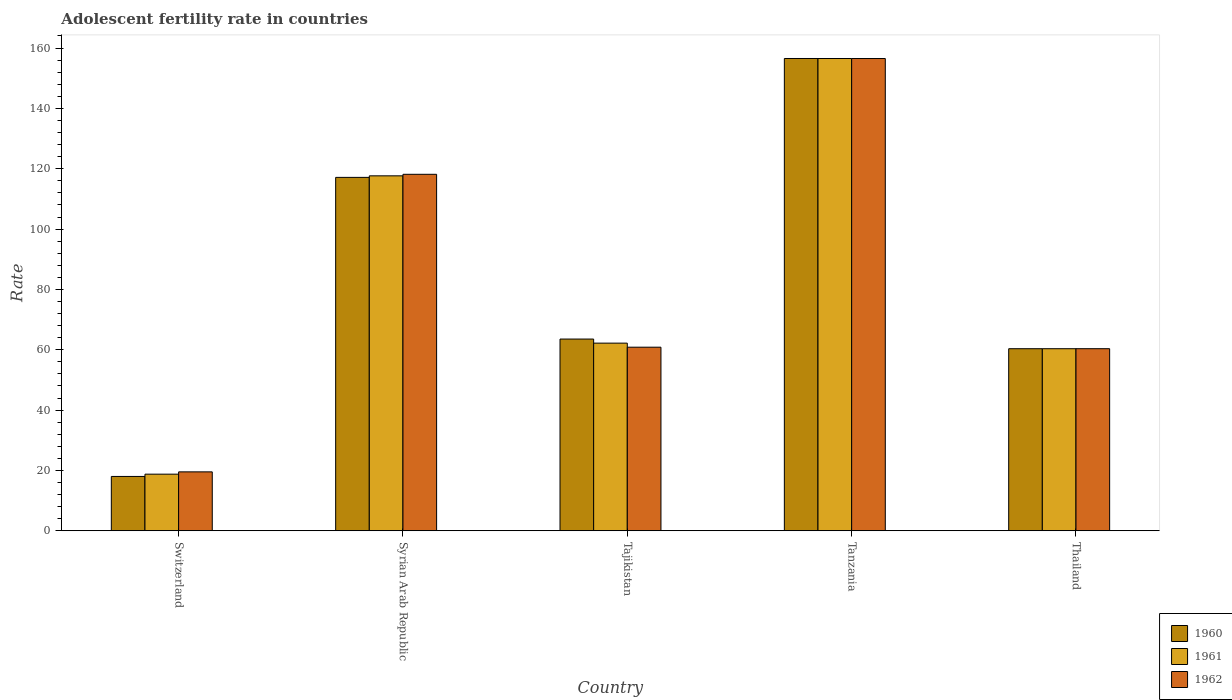How many different coloured bars are there?
Offer a very short reply. 3. How many groups of bars are there?
Provide a short and direct response. 5. Are the number of bars per tick equal to the number of legend labels?
Your answer should be very brief. Yes. What is the label of the 5th group of bars from the left?
Give a very brief answer. Thailand. What is the adolescent fertility rate in 1961 in Tanzania?
Give a very brief answer. 156.54. Across all countries, what is the maximum adolescent fertility rate in 1962?
Your answer should be very brief. 156.54. Across all countries, what is the minimum adolescent fertility rate in 1960?
Offer a very short reply. 18.01. In which country was the adolescent fertility rate in 1960 maximum?
Offer a terse response. Tanzania. In which country was the adolescent fertility rate in 1961 minimum?
Offer a terse response. Switzerland. What is the total adolescent fertility rate in 1962 in the graph?
Give a very brief answer. 415.43. What is the difference between the adolescent fertility rate in 1962 in Syrian Arab Republic and that in Thailand?
Ensure brevity in your answer.  57.81. What is the difference between the adolescent fertility rate in 1960 in Tajikistan and the adolescent fertility rate in 1962 in Thailand?
Make the answer very short. 3.2. What is the average adolescent fertility rate in 1961 per country?
Your response must be concise. 83.1. What is the difference between the adolescent fertility rate of/in 1961 and adolescent fertility rate of/in 1962 in Syrian Arab Republic?
Offer a terse response. -0.51. What is the ratio of the adolescent fertility rate in 1961 in Switzerland to that in Syrian Arab Republic?
Offer a very short reply. 0.16. What is the difference between the highest and the second highest adolescent fertility rate in 1961?
Offer a terse response. 38.89. What is the difference between the highest and the lowest adolescent fertility rate in 1960?
Your answer should be very brief. 138.53. In how many countries, is the adolescent fertility rate in 1962 greater than the average adolescent fertility rate in 1962 taken over all countries?
Your answer should be very brief. 2. Is the sum of the adolescent fertility rate in 1960 in Syrian Arab Republic and Tajikistan greater than the maximum adolescent fertility rate in 1961 across all countries?
Keep it short and to the point. Yes. What does the 1st bar from the left in Tanzania represents?
Make the answer very short. 1960. What does the 3rd bar from the right in Thailand represents?
Your answer should be very brief. 1960. Is it the case that in every country, the sum of the adolescent fertility rate in 1962 and adolescent fertility rate in 1961 is greater than the adolescent fertility rate in 1960?
Offer a terse response. Yes. How many bars are there?
Keep it short and to the point. 15. Are all the bars in the graph horizontal?
Provide a succinct answer. No. How many countries are there in the graph?
Provide a succinct answer. 5. Are the values on the major ticks of Y-axis written in scientific E-notation?
Keep it short and to the point. No. Where does the legend appear in the graph?
Provide a succinct answer. Bottom right. How are the legend labels stacked?
Give a very brief answer. Vertical. What is the title of the graph?
Give a very brief answer. Adolescent fertility rate in countries. Does "2005" appear as one of the legend labels in the graph?
Your answer should be compact. No. What is the label or title of the Y-axis?
Give a very brief answer. Rate. What is the Rate of 1960 in Switzerland?
Your answer should be very brief. 18.01. What is the Rate of 1961 in Switzerland?
Your answer should be compact. 18.77. What is the Rate in 1962 in Switzerland?
Make the answer very short. 19.53. What is the Rate of 1960 in Syrian Arab Republic?
Offer a very short reply. 117.14. What is the Rate of 1961 in Syrian Arab Republic?
Offer a very short reply. 117.65. What is the Rate of 1962 in Syrian Arab Republic?
Give a very brief answer. 118.16. What is the Rate of 1960 in Tajikistan?
Offer a terse response. 63.55. What is the Rate in 1961 in Tajikistan?
Your answer should be compact. 62.2. What is the Rate of 1962 in Tajikistan?
Offer a very short reply. 60.85. What is the Rate of 1960 in Tanzania?
Your answer should be very brief. 156.55. What is the Rate of 1961 in Tanzania?
Keep it short and to the point. 156.54. What is the Rate of 1962 in Tanzania?
Give a very brief answer. 156.54. What is the Rate in 1960 in Thailand?
Your response must be concise. 60.35. What is the Rate of 1961 in Thailand?
Offer a terse response. 60.35. What is the Rate of 1962 in Thailand?
Your response must be concise. 60.35. Across all countries, what is the maximum Rate in 1960?
Provide a succinct answer. 156.55. Across all countries, what is the maximum Rate in 1961?
Make the answer very short. 156.54. Across all countries, what is the maximum Rate of 1962?
Offer a very short reply. 156.54. Across all countries, what is the minimum Rate in 1960?
Ensure brevity in your answer.  18.01. Across all countries, what is the minimum Rate of 1961?
Offer a very short reply. 18.77. Across all countries, what is the minimum Rate of 1962?
Offer a very short reply. 19.53. What is the total Rate in 1960 in the graph?
Give a very brief answer. 415.59. What is the total Rate of 1961 in the graph?
Make the answer very short. 415.51. What is the total Rate of 1962 in the graph?
Your response must be concise. 415.43. What is the difference between the Rate in 1960 in Switzerland and that in Syrian Arab Republic?
Your response must be concise. -99.13. What is the difference between the Rate of 1961 in Switzerland and that in Syrian Arab Republic?
Your answer should be very brief. -98.88. What is the difference between the Rate of 1962 in Switzerland and that in Syrian Arab Republic?
Provide a succinct answer. -98.63. What is the difference between the Rate in 1960 in Switzerland and that in Tajikistan?
Your response must be concise. -45.54. What is the difference between the Rate of 1961 in Switzerland and that in Tajikistan?
Your answer should be compact. -43.43. What is the difference between the Rate of 1962 in Switzerland and that in Tajikistan?
Provide a short and direct response. -41.32. What is the difference between the Rate of 1960 in Switzerland and that in Tanzania?
Offer a very short reply. -138.53. What is the difference between the Rate of 1961 in Switzerland and that in Tanzania?
Make the answer very short. -137.77. What is the difference between the Rate in 1962 in Switzerland and that in Tanzania?
Ensure brevity in your answer.  -137.01. What is the difference between the Rate of 1960 in Switzerland and that in Thailand?
Offer a terse response. -42.34. What is the difference between the Rate of 1961 in Switzerland and that in Thailand?
Make the answer very short. -41.58. What is the difference between the Rate in 1962 in Switzerland and that in Thailand?
Keep it short and to the point. -40.82. What is the difference between the Rate in 1960 in Syrian Arab Republic and that in Tajikistan?
Provide a short and direct response. 53.59. What is the difference between the Rate in 1961 in Syrian Arab Republic and that in Tajikistan?
Give a very brief answer. 55.45. What is the difference between the Rate in 1962 in Syrian Arab Republic and that in Tajikistan?
Make the answer very short. 57.31. What is the difference between the Rate of 1960 in Syrian Arab Republic and that in Tanzania?
Your answer should be very brief. -39.41. What is the difference between the Rate of 1961 in Syrian Arab Republic and that in Tanzania?
Offer a terse response. -38.89. What is the difference between the Rate of 1962 in Syrian Arab Republic and that in Tanzania?
Make the answer very short. -38.38. What is the difference between the Rate in 1960 in Syrian Arab Republic and that in Thailand?
Your response must be concise. 56.79. What is the difference between the Rate of 1961 in Syrian Arab Republic and that in Thailand?
Ensure brevity in your answer.  57.3. What is the difference between the Rate in 1962 in Syrian Arab Republic and that in Thailand?
Keep it short and to the point. 57.81. What is the difference between the Rate of 1960 in Tajikistan and that in Tanzania?
Your response must be concise. -93. What is the difference between the Rate in 1961 in Tajikistan and that in Tanzania?
Keep it short and to the point. -94.34. What is the difference between the Rate of 1962 in Tajikistan and that in Tanzania?
Make the answer very short. -95.68. What is the difference between the Rate in 1960 in Tajikistan and that in Thailand?
Offer a very short reply. 3.2. What is the difference between the Rate in 1961 in Tajikistan and that in Thailand?
Your response must be concise. 1.85. What is the difference between the Rate in 1962 in Tajikistan and that in Thailand?
Provide a short and direct response. 0.5. What is the difference between the Rate in 1960 in Tanzania and that in Thailand?
Offer a terse response. 96.19. What is the difference between the Rate of 1961 in Tanzania and that in Thailand?
Your answer should be compact. 96.19. What is the difference between the Rate in 1962 in Tanzania and that in Thailand?
Your answer should be compact. 96.18. What is the difference between the Rate in 1960 in Switzerland and the Rate in 1961 in Syrian Arab Republic?
Offer a very short reply. -99.64. What is the difference between the Rate of 1960 in Switzerland and the Rate of 1962 in Syrian Arab Republic?
Ensure brevity in your answer.  -100.15. What is the difference between the Rate of 1961 in Switzerland and the Rate of 1962 in Syrian Arab Republic?
Offer a very short reply. -99.39. What is the difference between the Rate of 1960 in Switzerland and the Rate of 1961 in Tajikistan?
Make the answer very short. -44.19. What is the difference between the Rate of 1960 in Switzerland and the Rate of 1962 in Tajikistan?
Offer a very short reply. -42.84. What is the difference between the Rate in 1961 in Switzerland and the Rate in 1962 in Tajikistan?
Your answer should be compact. -42.08. What is the difference between the Rate in 1960 in Switzerland and the Rate in 1961 in Tanzania?
Give a very brief answer. -138.53. What is the difference between the Rate in 1960 in Switzerland and the Rate in 1962 in Tanzania?
Give a very brief answer. -138.52. What is the difference between the Rate of 1961 in Switzerland and the Rate of 1962 in Tanzania?
Your answer should be compact. -137.77. What is the difference between the Rate in 1960 in Switzerland and the Rate in 1961 in Thailand?
Offer a very short reply. -42.34. What is the difference between the Rate of 1960 in Switzerland and the Rate of 1962 in Thailand?
Your response must be concise. -42.34. What is the difference between the Rate of 1961 in Switzerland and the Rate of 1962 in Thailand?
Your answer should be compact. -41.58. What is the difference between the Rate in 1960 in Syrian Arab Republic and the Rate in 1961 in Tajikistan?
Offer a terse response. 54.94. What is the difference between the Rate in 1960 in Syrian Arab Republic and the Rate in 1962 in Tajikistan?
Give a very brief answer. 56.29. What is the difference between the Rate of 1961 in Syrian Arab Republic and the Rate of 1962 in Tajikistan?
Keep it short and to the point. 56.8. What is the difference between the Rate of 1960 in Syrian Arab Republic and the Rate of 1961 in Tanzania?
Offer a terse response. -39.4. What is the difference between the Rate in 1960 in Syrian Arab Republic and the Rate in 1962 in Tanzania?
Your response must be concise. -39.4. What is the difference between the Rate in 1961 in Syrian Arab Republic and the Rate in 1962 in Tanzania?
Your response must be concise. -38.89. What is the difference between the Rate of 1960 in Syrian Arab Republic and the Rate of 1961 in Thailand?
Offer a terse response. 56.79. What is the difference between the Rate in 1960 in Syrian Arab Republic and the Rate in 1962 in Thailand?
Offer a terse response. 56.78. What is the difference between the Rate in 1961 in Syrian Arab Republic and the Rate in 1962 in Thailand?
Your answer should be compact. 57.3. What is the difference between the Rate of 1960 in Tajikistan and the Rate of 1961 in Tanzania?
Give a very brief answer. -92.99. What is the difference between the Rate in 1960 in Tajikistan and the Rate in 1962 in Tanzania?
Make the answer very short. -92.99. What is the difference between the Rate of 1961 in Tajikistan and the Rate of 1962 in Tanzania?
Ensure brevity in your answer.  -94.34. What is the difference between the Rate of 1960 in Tajikistan and the Rate of 1961 in Thailand?
Your response must be concise. 3.2. What is the difference between the Rate in 1960 in Tajikistan and the Rate in 1962 in Thailand?
Your answer should be very brief. 3.2. What is the difference between the Rate in 1961 in Tajikistan and the Rate in 1962 in Thailand?
Offer a terse response. 1.85. What is the difference between the Rate in 1960 in Tanzania and the Rate in 1961 in Thailand?
Your answer should be compact. 96.19. What is the difference between the Rate of 1960 in Tanzania and the Rate of 1962 in Thailand?
Offer a very short reply. 96.19. What is the difference between the Rate in 1961 in Tanzania and the Rate in 1962 in Thailand?
Your answer should be very brief. 96.19. What is the average Rate in 1960 per country?
Ensure brevity in your answer.  83.12. What is the average Rate of 1961 per country?
Make the answer very short. 83.1. What is the average Rate in 1962 per country?
Provide a short and direct response. 83.09. What is the difference between the Rate of 1960 and Rate of 1961 in Switzerland?
Your response must be concise. -0.76. What is the difference between the Rate of 1960 and Rate of 1962 in Switzerland?
Keep it short and to the point. -1.52. What is the difference between the Rate in 1961 and Rate in 1962 in Switzerland?
Offer a very short reply. -0.76. What is the difference between the Rate of 1960 and Rate of 1961 in Syrian Arab Republic?
Your answer should be compact. -0.51. What is the difference between the Rate in 1960 and Rate in 1962 in Syrian Arab Republic?
Provide a short and direct response. -1.02. What is the difference between the Rate in 1961 and Rate in 1962 in Syrian Arab Republic?
Give a very brief answer. -0.51. What is the difference between the Rate in 1960 and Rate in 1961 in Tajikistan?
Offer a terse response. 1.35. What is the difference between the Rate of 1960 and Rate of 1962 in Tajikistan?
Keep it short and to the point. 2.7. What is the difference between the Rate in 1961 and Rate in 1962 in Tajikistan?
Give a very brief answer. 1.35. What is the difference between the Rate of 1960 and Rate of 1961 in Tanzania?
Keep it short and to the point. 0. What is the difference between the Rate in 1960 and Rate in 1962 in Tanzania?
Your answer should be very brief. 0.01. What is the difference between the Rate in 1961 and Rate in 1962 in Tanzania?
Your answer should be very brief. 0. What is the difference between the Rate in 1960 and Rate in 1961 in Thailand?
Your answer should be very brief. -0. What is the difference between the Rate in 1960 and Rate in 1962 in Thailand?
Offer a terse response. -0. What is the difference between the Rate in 1961 and Rate in 1962 in Thailand?
Your response must be concise. -0. What is the ratio of the Rate of 1960 in Switzerland to that in Syrian Arab Republic?
Your response must be concise. 0.15. What is the ratio of the Rate of 1961 in Switzerland to that in Syrian Arab Republic?
Give a very brief answer. 0.16. What is the ratio of the Rate in 1962 in Switzerland to that in Syrian Arab Republic?
Provide a short and direct response. 0.17. What is the ratio of the Rate of 1960 in Switzerland to that in Tajikistan?
Your answer should be very brief. 0.28. What is the ratio of the Rate of 1961 in Switzerland to that in Tajikistan?
Offer a very short reply. 0.3. What is the ratio of the Rate in 1962 in Switzerland to that in Tajikistan?
Ensure brevity in your answer.  0.32. What is the ratio of the Rate in 1960 in Switzerland to that in Tanzania?
Provide a succinct answer. 0.12. What is the ratio of the Rate of 1961 in Switzerland to that in Tanzania?
Provide a succinct answer. 0.12. What is the ratio of the Rate of 1962 in Switzerland to that in Tanzania?
Your answer should be very brief. 0.12. What is the ratio of the Rate in 1960 in Switzerland to that in Thailand?
Your response must be concise. 0.3. What is the ratio of the Rate of 1961 in Switzerland to that in Thailand?
Give a very brief answer. 0.31. What is the ratio of the Rate of 1962 in Switzerland to that in Thailand?
Keep it short and to the point. 0.32. What is the ratio of the Rate of 1960 in Syrian Arab Republic to that in Tajikistan?
Give a very brief answer. 1.84. What is the ratio of the Rate in 1961 in Syrian Arab Republic to that in Tajikistan?
Provide a succinct answer. 1.89. What is the ratio of the Rate of 1962 in Syrian Arab Republic to that in Tajikistan?
Offer a very short reply. 1.94. What is the ratio of the Rate in 1960 in Syrian Arab Republic to that in Tanzania?
Offer a terse response. 0.75. What is the ratio of the Rate of 1961 in Syrian Arab Republic to that in Tanzania?
Make the answer very short. 0.75. What is the ratio of the Rate in 1962 in Syrian Arab Republic to that in Tanzania?
Give a very brief answer. 0.75. What is the ratio of the Rate of 1960 in Syrian Arab Republic to that in Thailand?
Offer a very short reply. 1.94. What is the ratio of the Rate in 1961 in Syrian Arab Republic to that in Thailand?
Ensure brevity in your answer.  1.95. What is the ratio of the Rate of 1962 in Syrian Arab Republic to that in Thailand?
Keep it short and to the point. 1.96. What is the ratio of the Rate of 1960 in Tajikistan to that in Tanzania?
Provide a short and direct response. 0.41. What is the ratio of the Rate of 1961 in Tajikistan to that in Tanzania?
Offer a very short reply. 0.4. What is the ratio of the Rate of 1962 in Tajikistan to that in Tanzania?
Provide a short and direct response. 0.39. What is the ratio of the Rate of 1960 in Tajikistan to that in Thailand?
Give a very brief answer. 1.05. What is the ratio of the Rate in 1961 in Tajikistan to that in Thailand?
Give a very brief answer. 1.03. What is the ratio of the Rate of 1962 in Tajikistan to that in Thailand?
Your answer should be compact. 1.01. What is the ratio of the Rate of 1960 in Tanzania to that in Thailand?
Offer a very short reply. 2.59. What is the ratio of the Rate in 1961 in Tanzania to that in Thailand?
Provide a succinct answer. 2.59. What is the ratio of the Rate of 1962 in Tanzania to that in Thailand?
Your response must be concise. 2.59. What is the difference between the highest and the second highest Rate of 1960?
Your answer should be compact. 39.41. What is the difference between the highest and the second highest Rate of 1961?
Give a very brief answer. 38.89. What is the difference between the highest and the second highest Rate of 1962?
Your response must be concise. 38.38. What is the difference between the highest and the lowest Rate in 1960?
Offer a terse response. 138.53. What is the difference between the highest and the lowest Rate in 1961?
Your answer should be compact. 137.77. What is the difference between the highest and the lowest Rate in 1962?
Offer a very short reply. 137.01. 